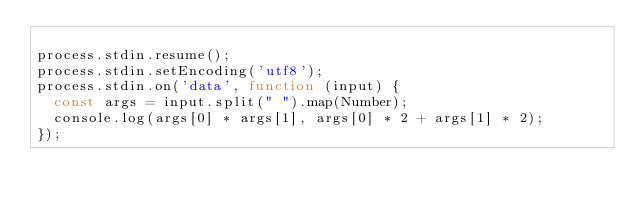Convert code to text. <code><loc_0><loc_0><loc_500><loc_500><_JavaScript_>
process.stdin.resume();
process.stdin.setEncoding('utf8');
process.stdin.on('data', function (input) {
  const args = input.split(" ").map(Number);
  console.log(args[0] * args[1], args[0] * 2 + args[1] * 2);
});</code> 